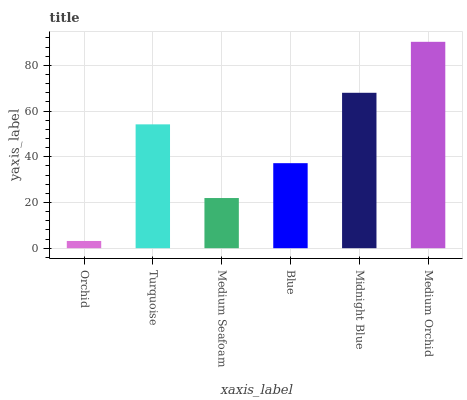Is Orchid the minimum?
Answer yes or no. Yes. Is Medium Orchid the maximum?
Answer yes or no. Yes. Is Turquoise the minimum?
Answer yes or no. No. Is Turquoise the maximum?
Answer yes or no. No. Is Turquoise greater than Orchid?
Answer yes or no. Yes. Is Orchid less than Turquoise?
Answer yes or no. Yes. Is Orchid greater than Turquoise?
Answer yes or no. No. Is Turquoise less than Orchid?
Answer yes or no. No. Is Turquoise the high median?
Answer yes or no. Yes. Is Blue the low median?
Answer yes or no. Yes. Is Medium Orchid the high median?
Answer yes or no. No. Is Turquoise the low median?
Answer yes or no. No. 